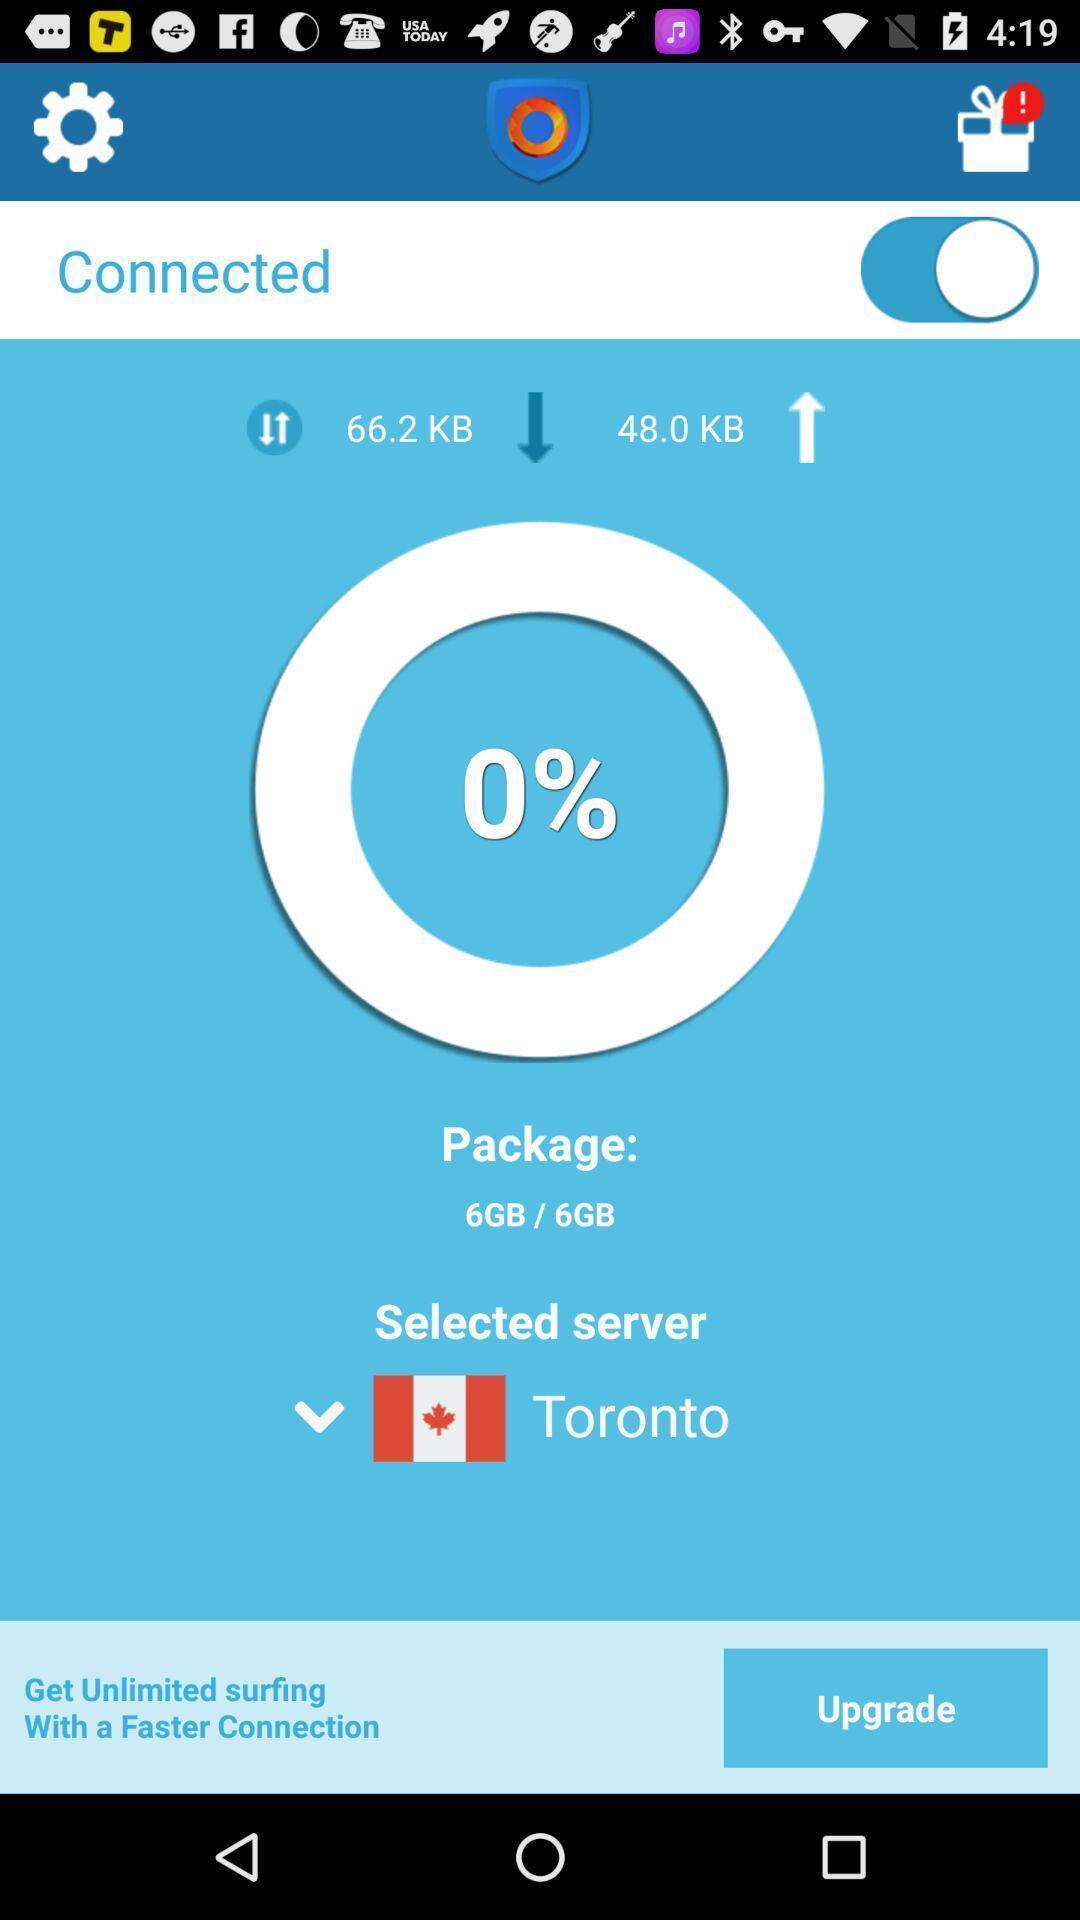Give me a narrative description of this picture. Screen displaying the speed for the server. 